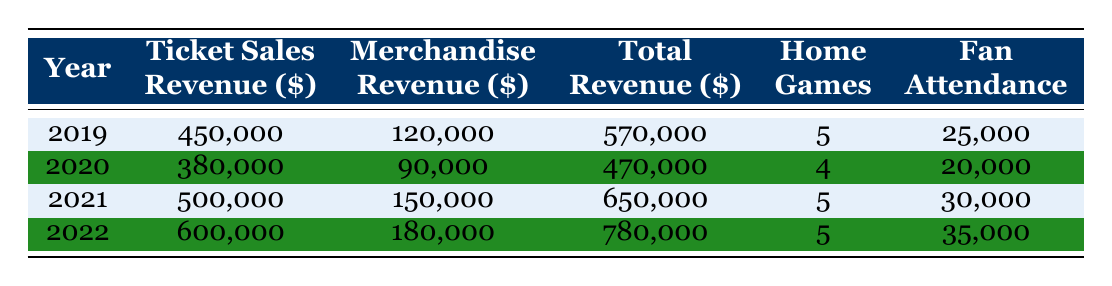What was the total revenue in 2021? The total revenue for 2021 is listed directly in the table as 650,000.
Answer: 650,000 Which year had the highest merchandise revenue? The merchandise revenue for each year is as follows: 2019 (120,000), 2020 (90,000), 2021 (150,000), and 2022 (180,000). The highest value is 180,000 in 2022.
Answer: 2022 What was the average ticket sales revenue over these four years? The ticket sales revenue over the four years is: 450,000 + 380,000 + 500,000 + 600,000 = 1,930,000. To find the average, divide by 4, yielding 1,930,000 / 4 = 482,500.
Answer: 482,500 Did the fan attendance increase every year? The fan attendance for each year is: 25,000 (2019), 20,000 (2020), 30,000 (2021), and 35,000 (2022). Since it decreased from 2019 to 2020, the statement is false.
Answer: No What was the increase in total revenue from 2020 to 2021? The total revenue in 2020 is 470,000, and in 2021 it is 650,000. The difference is 650,000 - 470,000 = 180,000.
Answer: 180,000 How much more revenue was generated from ticket sales than merchandise in 2022? Ticket sales revenue in 2022 is 600,000 and merchandise revenue is 180,000. The difference is 600,000 - 180,000 = 420,000.
Answer: 420,000 What was the total revenue in the years when there were 5 home games? The years with 5 home games are 2019, 2021, and 2022. Their total revenues are 570,000 (2019), 650,000 (2021), and 780,000 (2022). Adding these gives 570,000 + 650,000 + 780,000 = 2,000,000.
Answer: 2,000,000 In which year was the ticket sales revenue the lowest? Examining the ticket sales revenue, it was 450,000 in 2019, 380,000 in 2020, 500,000 in 2021, and 600,000 in 2022. The lowest value is 380,000 in 2020.
Answer: 2020 How much was the total revenue in 2020 compared to 2022? The total revenue in 2020 is 470,000 and in 2022 it is 780,000. The increase is 780,000 - 470,000 = 310,000.
Answer: 310,000 Is the fan attendance for 2021 greater than the average fan attendance over these four years? The average fan attendance is (25,000 + 20,000 + 30,000 + 35,000) / 4 = 27,500. The attendance in 2021 is 30,000, which is greater than 27,500, so the statement is true.
Answer: Yes 